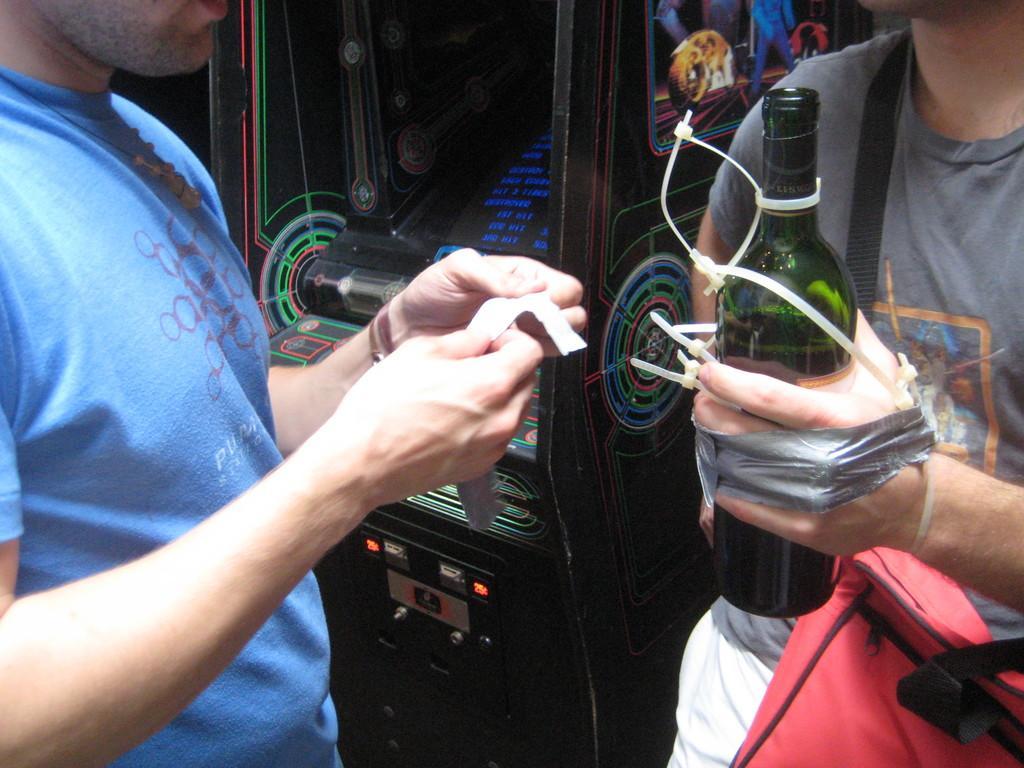Please provide a concise description of this image. In the image we can see there are people who are standing and holding wine bottle in their hand and the persons hand is tied with a ash colour tape and he is carrying a red colour bag and there is a music system at the back and the person is wearing blue colour t shirt. 